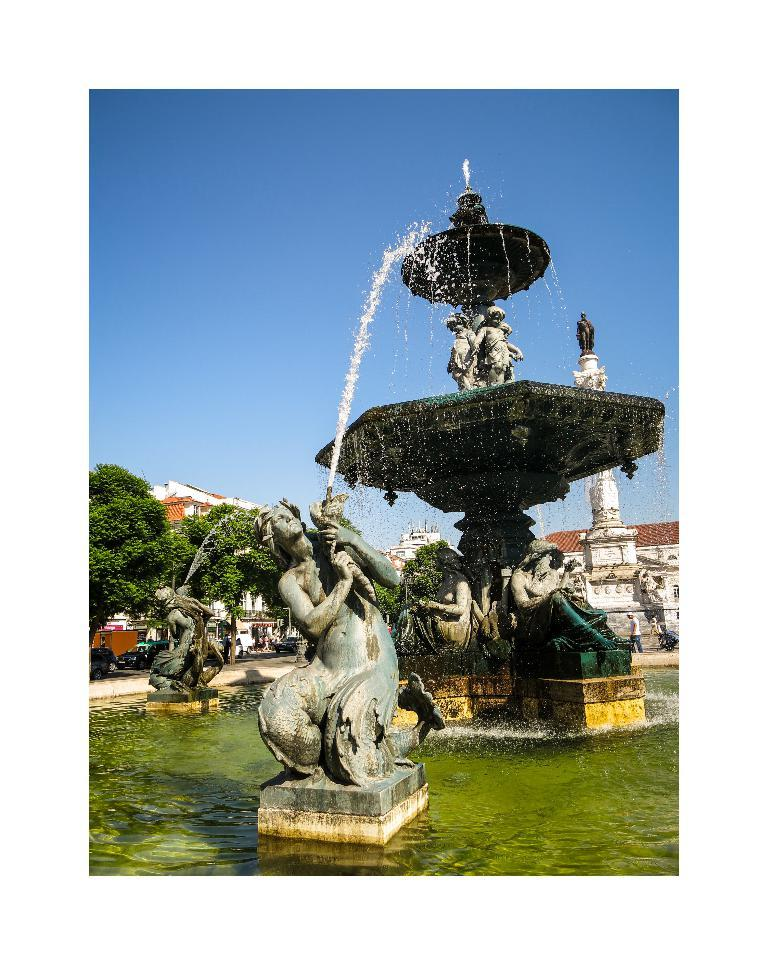What type of sculpture can be seen in the image? There is a water sculpture fountain in the image. What other types of sculptures are present in the image? There are sculptures in the image. What structures can be seen in the image? There are buildings in the image. What mode of transportation is visible in the image? There are vehicles in the image. What type of vegetation is present in the image? There are trees in the image. What is visible in the background of the image? The sky is visible in the background of the image. Can you tell me how many berries are on the trees in the image? There are no berries mentioned or visible in the image; it features a water sculpture fountain, sculptures, buildings, vehicles, trees, and a visible sky. Is there a train passing by in the image? There is no train present in the image. 